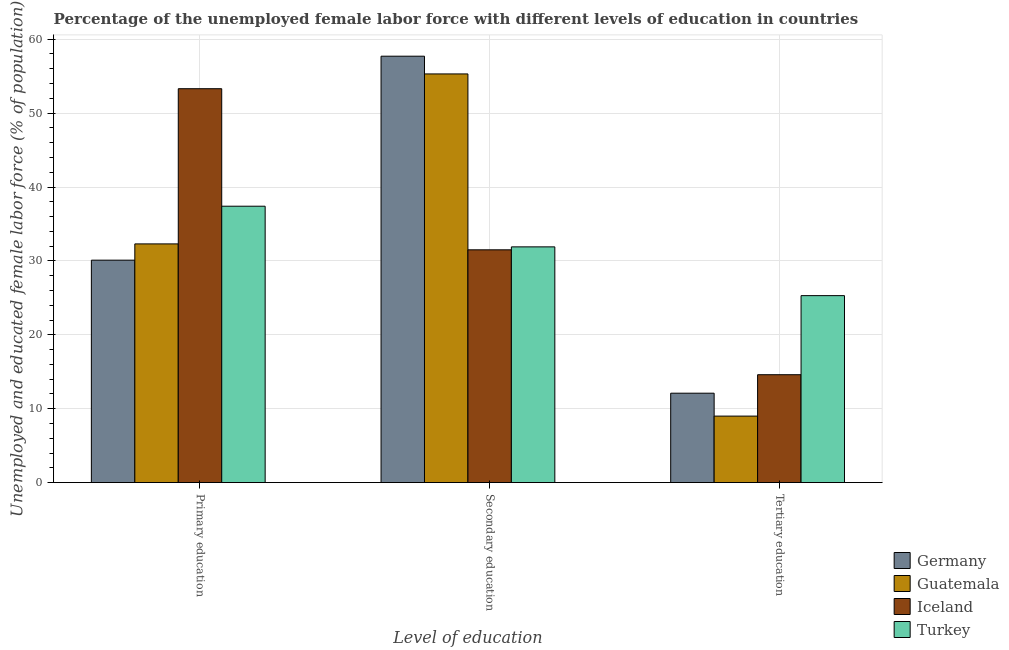How many groups of bars are there?
Your answer should be very brief. 3. What is the label of the 3rd group of bars from the left?
Offer a very short reply. Tertiary education. What is the percentage of female labor force who received tertiary education in Iceland?
Ensure brevity in your answer.  14.6. Across all countries, what is the maximum percentage of female labor force who received secondary education?
Provide a succinct answer. 57.7. Across all countries, what is the minimum percentage of female labor force who received secondary education?
Your answer should be compact. 31.5. What is the total percentage of female labor force who received secondary education in the graph?
Your answer should be very brief. 176.4. What is the difference between the percentage of female labor force who received secondary education in Iceland and that in Guatemala?
Provide a short and direct response. -23.8. What is the difference between the percentage of female labor force who received tertiary education in Germany and the percentage of female labor force who received secondary education in Iceland?
Keep it short and to the point. -19.4. What is the average percentage of female labor force who received secondary education per country?
Your answer should be very brief. 44.1. What is the difference between the percentage of female labor force who received primary education and percentage of female labor force who received secondary education in Iceland?
Your response must be concise. 21.8. In how many countries, is the percentage of female labor force who received primary education greater than 52 %?
Ensure brevity in your answer.  1. What is the ratio of the percentage of female labor force who received secondary education in Turkey to that in Guatemala?
Offer a very short reply. 0.58. What is the difference between the highest and the second highest percentage of female labor force who received tertiary education?
Offer a very short reply. 10.7. What is the difference between the highest and the lowest percentage of female labor force who received tertiary education?
Make the answer very short. 16.3. In how many countries, is the percentage of female labor force who received primary education greater than the average percentage of female labor force who received primary education taken over all countries?
Provide a short and direct response. 1. Is the sum of the percentage of female labor force who received secondary education in Turkey and Guatemala greater than the maximum percentage of female labor force who received tertiary education across all countries?
Ensure brevity in your answer.  Yes. What does the 2nd bar from the left in Secondary education represents?
Offer a very short reply. Guatemala. What does the 2nd bar from the right in Secondary education represents?
Keep it short and to the point. Iceland. How many bars are there?
Make the answer very short. 12. How many countries are there in the graph?
Your answer should be compact. 4. What is the difference between two consecutive major ticks on the Y-axis?
Your response must be concise. 10. Are the values on the major ticks of Y-axis written in scientific E-notation?
Provide a succinct answer. No. Does the graph contain any zero values?
Provide a succinct answer. No. Where does the legend appear in the graph?
Your answer should be compact. Bottom right. What is the title of the graph?
Offer a terse response. Percentage of the unemployed female labor force with different levels of education in countries. What is the label or title of the X-axis?
Give a very brief answer. Level of education. What is the label or title of the Y-axis?
Offer a terse response. Unemployed and educated female labor force (% of population). What is the Unemployed and educated female labor force (% of population) of Germany in Primary education?
Your answer should be compact. 30.1. What is the Unemployed and educated female labor force (% of population) in Guatemala in Primary education?
Your response must be concise. 32.3. What is the Unemployed and educated female labor force (% of population) in Iceland in Primary education?
Your answer should be compact. 53.3. What is the Unemployed and educated female labor force (% of population) in Turkey in Primary education?
Provide a succinct answer. 37.4. What is the Unemployed and educated female labor force (% of population) of Germany in Secondary education?
Your answer should be very brief. 57.7. What is the Unemployed and educated female labor force (% of population) in Guatemala in Secondary education?
Provide a short and direct response. 55.3. What is the Unemployed and educated female labor force (% of population) in Iceland in Secondary education?
Make the answer very short. 31.5. What is the Unemployed and educated female labor force (% of population) of Turkey in Secondary education?
Your answer should be very brief. 31.9. What is the Unemployed and educated female labor force (% of population) of Germany in Tertiary education?
Your answer should be compact. 12.1. What is the Unemployed and educated female labor force (% of population) in Guatemala in Tertiary education?
Keep it short and to the point. 9. What is the Unemployed and educated female labor force (% of population) of Iceland in Tertiary education?
Your answer should be very brief. 14.6. What is the Unemployed and educated female labor force (% of population) in Turkey in Tertiary education?
Offer a terse response. 25.3. Across all Level of education, what is the maximum Unemployed and educated female labor force (% of population) of Germany?
Your answer should be very brief. 57.7. Across all Level of education, what is the maximum Unemployed and educated female labor force (% of population) of Guatemala?
Offer a very short reply. 55.3. Across all Level of education, what is the maximum Unemployed and educated female labor force (% of population) of Iceland?
Make the answer very short. 53.3. Across all Level of education, what is the maximum Unemployed and educated female labor force (% of population) of Turkey?
Ensure brevity in your answer.  37.4. Across all Level of education, what is the minimum Unemployed and educated female labor force (% of population) in Germany?
Keep it short and to the point. 12.1. Across all Level of education, what is the minimum Unemployed and educated female labor force (% of population) of Iceland?
Provide a succinct answer. 14.6. Across all Level of education, what is the minimum Unemployed and educated female labor force (% of population) of Turkey?
Keep it short and to the point. 25.3. What is the total Unemployed and educated female labor force (% of population) of Germany in the graph?
Your answer should be compact. 99.9. What is the total Unemployed and educated female labor force (% of population) in Guatemala in the graph?
Ensure brevity in your answer.  96.6. What is the total Unemployed and educated female labor force (% of population) of Iceland in the graph?
Ensure brevity in your answer.  99.4. What is the total Unemployed and educated female labor force (% of population) in Turkey in the graph?
Make the answer very short. 94.6. What is the difference between the Unemployed and educated female labor force (% of population) of Germany in Primary education and that in Secondary education?
Give a very brief answer. -27.6. What is the difference between the Unemployed and educated female labor force (% of population) in Iceland in Primary education and that in Secondary education?
Provide a succinct answer. 21.8. What is the difference between the Unemployed and educated female labor force (% of population) in Turkey in Primary education and that in Secondary education?
Ensure brevity in your answer.  5.5. What is the difference between the Unemployed and educated female labor force (% of population) in Germany in Primary education and that in Tertiary education?
Provide a short and direct response. 18. What is the difference between the Unemployed and educated female labor force (% of population) in Guatemala in Primary education and that in Tertiary education?
Your answer should be compact. 23.3. What is the difference between the Unemployed and educated female labor force (% of population) of Iceland in Primary education and that in Tertiary education?
Provide a succinct answer. 38.7. What is the difference between the Unemployed and educated female labor force (% of population) of Turkey in Primary education and that in Tertiary education?
Keep it short and to the point. 12.1. What is the difference between the Unemployed and educated female labor force (% of population) of Germany in Secondary education and that in Tertiary education?
Provide a succinct answer. 45.6. What is the difference between the Unemployed and educated female labor force (% of population) in Guatemala in Secondary education and that in Tertiary education?
Provide a succinct answer. 46.3. What is the difference between the Unemployed and educated female labor force (% of population) in Germany in Primary education and the Unemployed and educated female labor force (% of population) in Guatemala in Secondary education?
Provide a short and direct response. -25.2. What is the difference between the Unemployed and educated female labor force (% of population) of Germany in Primary education and the Unemployed and educated female labor force (% of population) of Turkey in Secondary education?
Offer a terse response. -1.8. What is the difference between the Unemployed and educated female labor force (% of population) in Guatemala in Primary education and the Unemployed and educated female labor force (% of population) in Iceland in Secondary education?
Offer a very short reply. 0.8. What is the difference between the Unemployed and educated female labor force (% of population) in Guatemala in Primary education and the Unemployed and educated female labor force (% of population) in Turkey in Secondary education?
Provide a short and direct response. 0.4. What is the difference between the Unemployed and educated female labor force (% of population) of Iceland in Primary education and the Unemployed and educated female labor force (% of population) of Turkey in Secondary education?
Your answer should be compact. 21.4. What is the difference between the Unemployed and educated female labor force (% of population) of Germany in Primary education and the Unemployed and educated female labor force (% of population) of Guatemala in Tertiary education?
Your response must be concise. 21.1. What is the difference between the Unemployed and educated female labor force (% of population) in Germany in Primary education and the Unemployed and educated female labor force (% of population) in Turkey in Tertiary education?
Make the answer very short. 4.8. What is the difference between the Unemployed and educated female labor force (% of population) of Guatemala in Primary education and the Unemployed and educated female labor force (% of population) of Iceland in Tertiary education?
Offer a very short reply. 17.7. What is the difference between the Unemployed and educated female labor force (% of population) of Germany in Secondary education and the Unemployed and educated female labor force (% of population) of Guatemala in Tertiary education?
Offer a very short reply. 48.7. What is the difference between the Unemployed and educated female labor force (% of population) of Germany in Secondary education and the Unemployed and educated female labor force (% of population) of Iceland in Tertiary education?
Your answer should be very brief. 43.1. What is the difference between the Unemployed and educated female labor force (% of population) of Germany in Secondary education and the Unemployed and educated female labor force (% of population) of Turkey in Tertiary education?
Offer a terse response. 32.4. What is the difference between the Unemployed and educated female labor force (% of population) in Guatemala in Secondary education and the Unemployed and educated female labor force (% of population) in Iceland in Tertiary education?
Your response must be concise. 40.7. What is the difference between the Unemployed and educated female labor force (% of population) of Guatemala in Secondary education and the Unemployed and educated female labor force (% of population) of Turkey in Tertiary education?
Keep it short and to the point. 30. What is the average Unemployed and educated female labor force (% of population) of Germany per Level of education?
Ensure brevity in your answer.  33.3. What is the average Unemployed and educated female labor force (% of population) in Guatemala per Level of education?
Ensure brevity in your answer.  32.2. What is the average Unemployed and educated female labor force (% of population) in Iceland per Level of education?
Your answer should be compact. 33.13. What is the average Unemployed and educated female labor force (% of population) of Turkey per Level of education?
Provide a succinct answer. 31.53. What is the difference between the Unemployed and educated female labor force (% of population) of Germany and Unemployed and educated female labor force (% of population) of Guatemala in Primary education?
Provide a succinct answer. -2.2. What is the difference between the Unemployed and educated female labor force (% of population) of Germany and Unemployed and educated female labor force (% of population) of Iceland in Primary education?
Keep it short and to the point. -23.2. What is the difference between the Unemployed and educated female labor force (% of population) in Germany and Unemployed and educated female labor force (% of population) in Turkey in Primary education?
Ensure brevity in your answer.  -7.3. What is the difference between the Unemployed and educated female labor force (% of population) of Iceland and Unemployed and educated female labor force (% of population) of Turkey in Primary education?
Provide a short and direct response. 15.9. What is the difference between the Unemployed and educated female labor force (% of population) in Germany and Unemployed and educated female labor force (% of population) in Guatemala in Secondary education?
Your answer should be very brief. 2.4. What is the difference between the Unemployed and educated female labor force (% of population) in Germany and Unemployed and educated female labor force (% of population) in Iceland in Secondary education?
Your answer should be compact. 26.2. What is the difference between the Unemployed and educated female labor force (% of population) in Germany and Unemployed and educated female labor force (% of population) in Turkey in Secondary education?
Offer a terse response. 25.8. What is the difference between the Unemployed and educated female labor force (% of population) in Guatemala and Unemployed and educated female labor force (% of population) in Iceland in Secondary education?
Ensure brevity in your answer.  23.8. What is the difference between the Unemployed and educated female labor force (% of population) in Guatemala and Unemployed and educated female labor force (% of population) in Turkey in Secondary education?
Give a very brief answer. 23.4. What is the difference between the Unemployed and educated female labor force (% of population) of Iceland and Unemployed and educated female labor force (% of population) of Turkey in Secondary education?
Your answer should be compact. -0.4. What is the difference between the Unemployed and educated female labor force (% of population) in Guatemala and Unemployed and educated female labor force (% of population) in Turkey in Tertiary education?
Your response must be concise. -16.3. What is the ratio of the Unemployed and educated female labor force (% of population) of Germany in Primary education to that in Secondary education?
Make the answer very short. 0.52. What is the ratio of the Unemployed and educated female labor force (% of population) in Guatemala in Primary education to that in Secondary education?
Give a very brief answer. 0.58. What is the ratio of the Unemployed and educated female labor force (% of population) of Iceland in Primary education to that in Secondary education?
Give a very brief answer. 1.69. What is the ratio of the Unemployed and educated female labor force (% of population) of Turkey in Primary education to that in Secondary education?
Keep it short and to the point. 1.17. What is the ratio of the Unemployed and educated female labor force (% of population) in Germany in Primary education to that in Tertiary education?
Ensure brevity in your answer.  2.49. What is the ratio of the Unemployed and educated female labor force (% of population) of Guatemala in Primary education to that in Tertiary education?
Make the answer very short. 3.59. What is the ratio of the Unemployed and educated female labor force (% of population) of Iceland in Primary education to that in Tertiary education?
Offer a terse response. 3.65. What is the ratio of the Unemployed and educated female labor force (% of population) in Turkey in Primary education to that in Tertiary education?
Provide a short and direct response. 1.48. What is the ratio of the Unemployed and educated female labor force (% of population) of Germany in Secondary education to that in Tertiary education?
Your response must be concise. 4.77. What is the ratio of the Unemployed and educated female labor force (% of population) of Guatemala in Secondary education to that in Tertiary education?
Give a very brief answer. 6.14. What is the ratio of the Unemployed and educated female labor force (% of population) of Iceland in Secondary education to that in Tertiary education?
Provide a succinct answer. 2.16. What is the ratio of the Unemployed and educated female labor force (% of population) of Turkey in Secondary education to that in Tertiary education?
Make the answer very short. 1.26. What is the difference between the highest and the second highest Unemployed and educated female labor force (% of population) of Germany?
Your answer should be compact. 27.6. What is the difference between the highest and the second highest Unemployed and educated female labor force (% of population) of Guatemala?
Offer a terse response. 23. What is the difference between the highest and the second highest Unemployed and educated female labor force (% of population) in Iceland?
Your answer should be compact. 21.8. What is the difference between the highest and the lowest Unemployed and educated female labor force (% of population) of Germany?
Your answer should be compact. 45.6. What is the difference between the highest and the lowest Unemployed and educated female labor force (% of population) of Guatemala?
Provide a succinct answer. 46.3. What is the difference between the highest and the lowest Unemployed and educated female labor force (% of population) of Iceland?
Ensure brevity in your answer.  38.7. What is the difference between the highest and the lowest Unemployed and educated female labor force (% of population) in Turkey?
Offer a terse response. 12.1. 